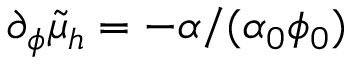Convert formula to latex. <formula><loc_0><loc_0><loc_500><loc_500>\partial _ { \phi } \tilde { \mu } _ { h } = - \alpha / ( \alpha _ { 0 } \phi _ { 0 } )</formula> 